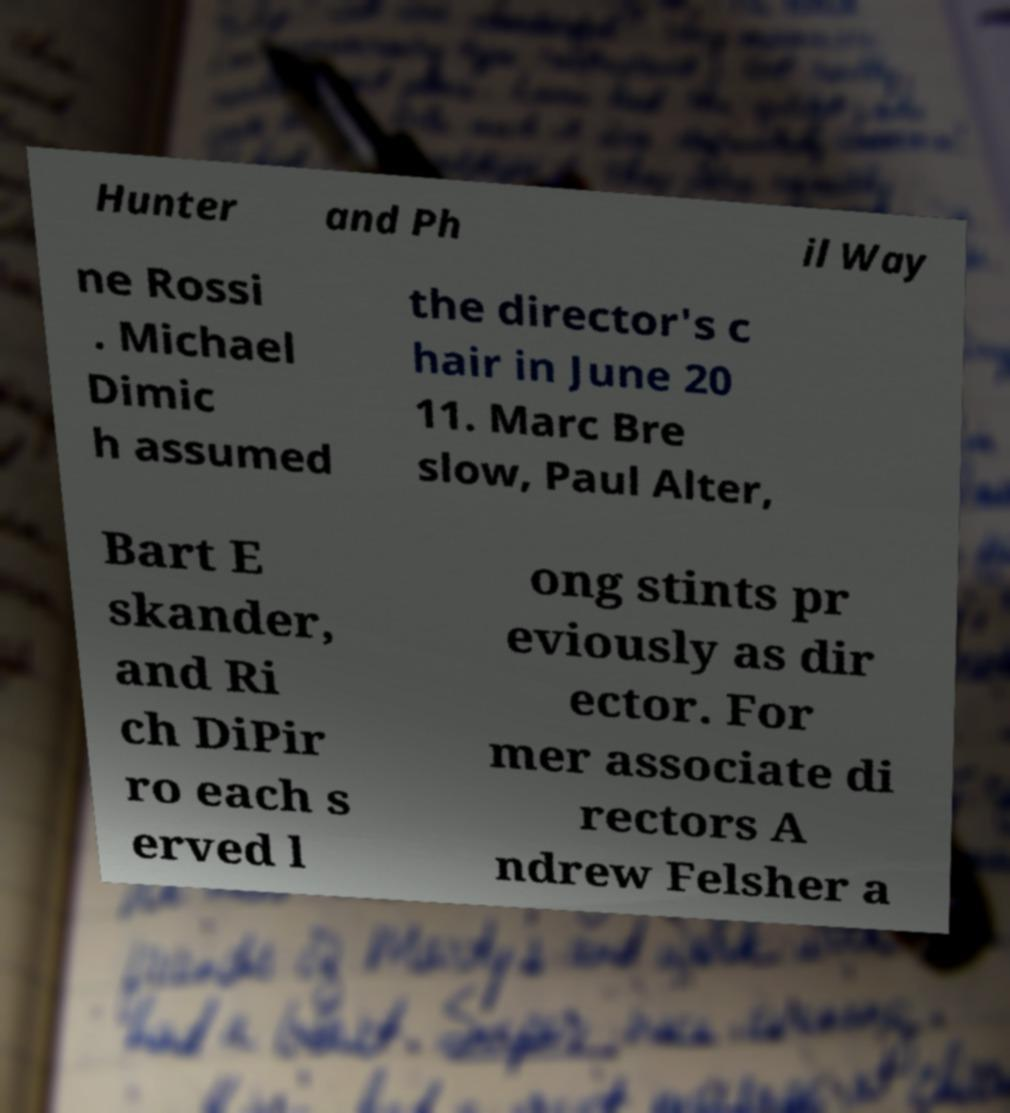Please read and relay the text visible in this image. What does it say? Hunter and Ph il Way ne Rossi . Michael Dimic h assumed the director's c hair in June 20 11. Marc Bre slow, Paul Alter, Bart E skander, and Ri ch DiPir ro each s erved l ong stints pr eviously as dir ector. For mer associate di rectors A ndrew Felsher a 